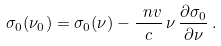Convert formula to latex. <formula><loc_0><loc_0><loc_500><loc_500>\sigma _ { 0 } ( \nu _ { 0 } ) = \sigma _ { 0 } ( \nu ) - \frac { \ n v } { c } \, \nu \, \frac { \partial \sigma _ { 0 } } { \partial \nu } \, .</formula> 